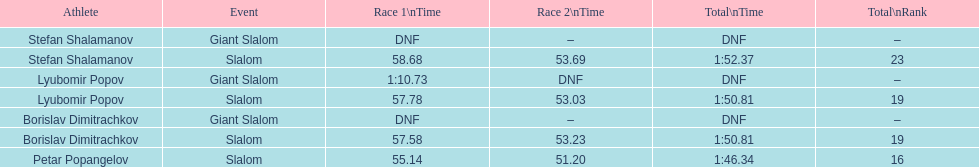What is the number of athletes to finish race one in the giant slalom? 1. 